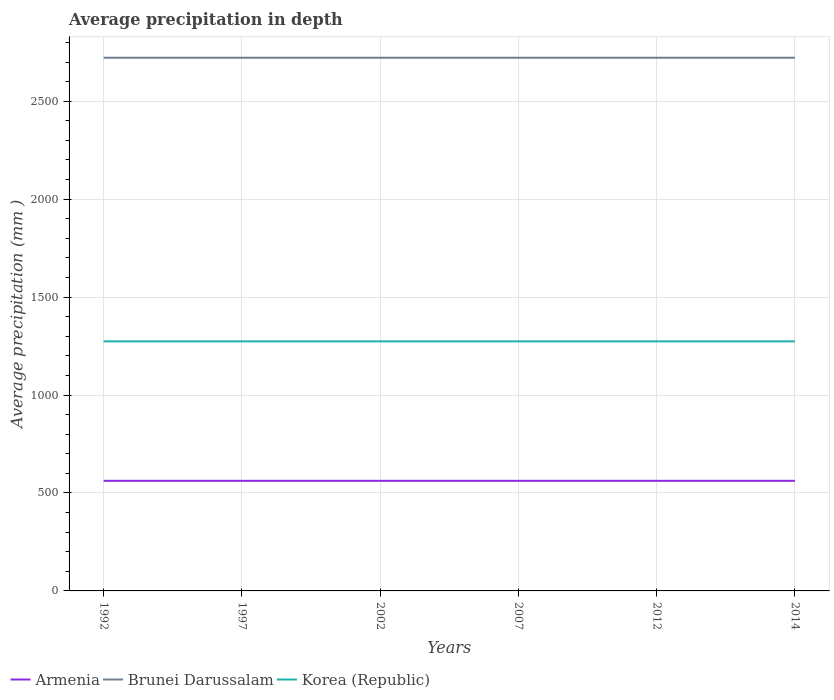How many different coloured lines are there?
Provide a succinct answer. 3. Does the line corresponding to Armenia intersect with the line corresponding to Korea (Republic)?
Provide a succinct answer. No. Is the number of lines equal to the number of legend labels?
Your answer should be very brief. Yes. Across all years, what is the maximum average precipitation in Korea (Republic)?
Ensure brevity in your answer.  1274. What is the total average precipitation in Korea (Republic) in the graph?
Your answer should be very brief. 0. Is the average precipitation in Brunei Darussalam strictly greater than the average precipitation in Korea (Republic) over the years?
Your answer should be very brief. No. Are the values on the major ticks of Y-axis written in scientific E-notation?
Your answer should be very brief. No. How many legend labels are there?
Your response must be concise. 3. What is the title of the graph?
Offer a very short reply. Average precipitation in depth. Does "Haiti" appear as one of the legend labels in the graph?
Keep it short and to the point. No. What is the label or title of the Y-axis?
Offer a terse response. Average precipitation (mm ). What is the Average precipitation (mm ) of Armenia in 1992?
Offer a very short reply. 562. What is the Average precipitation (mm ) of Brunei Darussalam in 1992?
Your answer should be compact. 2722. What is the Average precipitation (mm ) in Korea (Republic) in 1992?
Offer a terse response. 1274. What is the Average precipitation (mm ) of Armenia in 1997?
Give a very brief answer. 562. What is the Average precipitation (mm ) of Brunei Darussalam in 1997?
Your answer should be very brief. 2722. What is the Average precipitation (mm ) in Korea (Republic) in 1997?
Ensure brevity in your answer.  1274. What is the Average precipitation (mm ) of Armenia in 2002?
Provide a succinct answer. 562. What is the Average precipitation (mm ) in Brunei Darussalam in 2002?
Make the answer very short. 2722. What is the Average precipitation (mm ) in Korea (Republic) in 2002?
Your answer should be compact. 1274. What is the Average precipitation (mm ) of Armenia in 2007?
Provide a succinct answer. 562. What is the Average precipitation (mm ) in Brunei Darussalam in 2007?
Keep it short and to the point. 2722. What is the Average precipitation (mm ) of Korea (Republic) in 2007?
Your answer should be very brief. 1274. What is the Average precipitation (mm ) in Armenia in 2012?
Give a very brief answer. 562. What is the Average precipitation (mm ) in Brunei Darussalam in 2012?
Ensure brevity in your answer.  2722. What is the Average precipitation (mm ) in Korea (Republic) in 2012?
Provide a short and direct response. 1274. What is the Average precipitation (mm ) of Armenia in 2014?
Your response must be concise. 562. What is the Average precipitation (mm ) of Brunei Darussalam in 2014?
Offer a very short reply. 2722. What is the Average precipitation (mm ) of Korea (Republic) in 2014?
Provide a succinct answer. 1274. Across all years, what is the maximum Average precipitation (mm ) in Armenia?
Your response must be concise. 562. Across all years, what is the maximum Average precipitation (mm ) in Brunei Darussalam?
Offer a very short reply. 2722. Across all years, what is the maximum Average precipitation (mm ) in Korea (Republic)?
Offer a very short reply. 1274. Across all years, what is the minimum Average precipitation (mm ) in Armenia?
Provide a short and direct response. 562. Across all years, what is the minimum Average precipitation (mm ) of Brunei Darussalam?
Offer a very short reply. 2722. Across all years, what is the minimum Average precipitation (mm ) of Korea (Republic)?
Keep it short and to the point. 1274. What is the total Average precipitation (mm ) of Armenia in the graph?
Provide a succinct answer. 3372. What is the total Average precipitation (mm ) of Brunei Darussalam in the graph?
Offer a terse response. 1.63e+04. What is the total Average precipitation (mm ) in Korea (Republic) in the graph?
Give a very brief answer. 7644. What is the difference between the Average precipitation (mm ) of Armenia in 1992 and that in 1997?
Ensure brevity in your answer.  0. What is the difference between the Average precipitation (mm ) in Brunei Darussalam in 1992 and that in 1997?
Your answer should be compact. 0. What is the difference between the Average precipitation (mm ) of Korea (Republic) in 1992 and that in 1997?
Provide a succinct answer. 0. What is the difference between the Average precipitation (mm ) in Korea (Republic) in 1992 and that in 2002?
Give a very brief answer. 0. What is the difference between the Average precipitation (mm ) in Armenia in 1992 and that in 2007?
Give a very brief answer. 0. What is the difference between the Average precipitation (mm ) in Brunei Darussalam in 1992 and that in 2012?
Provide a short and direct response. 0. What is the difference between the Average precipitation (mm ) in Korea (Republic) in 1992 and that in 2012?
Your answer should be compact. 0. What is the difference between the Average precipitation (mm ) in Korea (Republic) in 1997 and that in 2002?
Give a very brief answer. 0. What is the difference between the Average precipitation (mm ) of Brunei Darussalam in 1997 and that in 2012?
Provide a short and direct response. 0. What is the difference between the Average precipitation (mm ) of Korea (Republic) in 1997 and that in 2014?
Your answer should be compact. 0. What is the difference between the Average precipitation (mm ) of Korea (Republic) in 2002 and that in 2012?
Offer a very short reply. 0. What is the difference between the Average precipitation (mm ) of Armenia in 2002 and that in 2014?
Offer a terse response. 0. What is the difference between the Average precipitation (mm ) in Korea (Republic) in 2007 and that in 2012?
Provide a short and direct response. 0. What is the difference between the Average precipitation (mm ) in Armenia in 2007 and that in 2014?
Your answer should be very brief. 0. What is the difference between the Average precipitation (mm ) of Brunei Darussalam in 2007 and that in 2014?
Offer a terse response. 0. What is the difference between the Average precipitation (mm ) of Armenia in 2012 and that in 2014?
Keep it short and to the point. 0. What is the difference between the Average precipitation (mm ) of Armenia in 1992 and the Average precipitation (mm ) of Brunei Darussalam in 1997?
Your answer should be very brief. -2160. What is the difference between the Average precipitation (mm ) of Armenia in 1992 and the Average precipitation (mm ) of Korea (Republic) in 1997?
Ensure brevity in your answer.  -712. What is the difference between the Average precipitation (mm ) of Brunei Darussalam in 1992 and the Average precipitation (mm ) of Korea (Republic) in 1997?
Offer a terse response. 1448. What is the difference between the Average precipitation (mm ) in Armenia in 1992 and the Average precipitation (mm ) in Brunei Darussalam in 2002?
Your response must be concise. -2160. What is the difference between the Average precipitation (mm ) of Armenia in 1992 and the Average precipitation (mm ) of Korea (Republic) in 2002?
Provide a short and direct response. -712. What is the difference between the Average precipitation (mm ) of Brunei Darussalam in 1992 and the Average precipitation (mm ) of Korea (Republic) in 2002?
Ensure brevity in your answer.  1448. What is the difference between the Average precipitation (mm ) of Armenia in 1992 and the Average precipitation (mm ) of Brunei Darussalam in 2007?
Ensure brevity in your answer.  -2160. What is the difference between the Average precipitation (mm ) of Armenia in 1992 and the Average precipitation (mm ) of Korea (Republic) in 2007?
Provide a short and direct response. -712. What is the difference between the Average precipitation (mm ) of Brunei Darussalam in 1992 and the Average precipitation (mm ) of Korea (Republic) in 2007?
Offer a very short reply. 1448. What is the difference between the Average precipitation (mm ) in Armenia in 1992 and the Average precipitation (mm ) in Brunei Darussalam in 2012?
Offer a very short reply. -2160. What is the difference between the Average precipitation (mm ) in Armenia in 1992 and the Average precipitation (mm ) in Korea (Republic) in 2012?
Provide a succinct answer. -712. What is the difference between the Average precipitation (mm ) of Brunei Darussalam in 1992 and the Average precipitation (mm ) of Korea (Republic) in 2012?
Your response must be concise. 1448. What is the difference between the Average precipitation (mm ) in Armenia in 1992 and the Average precipitation (mm ) in Brunei Darussalam in 2014?
Keep it short and to the point. -2160. What is the difference between the Average precipitation (mm ) in Armenia in 1992 and the Average precipitation (mm ) in Korea (Republic) in 2014?
Provide a succinct answer. -712. What is the difference between the Average precipitation (mm ) in Brunei Darussalam in 1992 and the Average precipitation (mm ) in Korea (Republic) in 2014?
Make the answer very short. 1448. What is the difference between the Average precipitation (mm ) in Armenia in 1997 and the Average precipitation (mm ) in Brunei Darussalam in 2002?
Keep it short and to the point. -2160. What is the difference between the Average precipitation (mm ) in Armenia in 1997 and the Average precipitation (mm ) in Korea (Republic) in 2002?
Your answer should be very brief. -712. What is the difference between the Average precipitation (mm ) in Brunei Darussalam in 1997 and the Average precipitation (mm ) in Korea (Republic) in 2002?
Keep it short and to the point. 1448. What is the difference between the Average precipitation (mm ) in Armenia in 1997 and the Average precipitation (mm ) in Brunei Darussalam in 2007?
Offer a very short reply. -2160. What is the difference between the Average precipitation (mm ) in Armenia in 1997 and the Average precipitation (mm ) in Korea (Republic) in 2007?
Give a very brief answer. -712. What is the difference between the Average precipitation (mm ) of Brunei Darussalam in 1997 and the Average precipitation (mm ) of Korea (Republic) in 2007?
Make the answer very short. 1448. What is the difference between the Average precipitation (mm ) in Armenia in 1997 and the Average precipitation (mm ) in Brunei Darussalam in 2012?
Make the answer very short. -2160. What is the difference between the Average precipitation (mm ) in Armenia in 1997 and the Average precipitation (mm ) in Korea (Republic) in 2012?
Provide a short and direct response. -712. What is the difference between the Average precipitation (mm ) in Brunei Darussalam in 1997 and the Average precipitation (mm ) in Korea (Republic) in 2012?
Offer a terse response. 1448. What is the difference between the Average precipitation (mm ) in Armenia in 1997 and the Average precipitation (mm ) in Brunei Darussalam in 2014?
Offer a terse response. -2160. What is the difference between the Average precipitation (mm ) in Armenia in 1997 and the Average precipitation (mm ) in Korea (Republic) in 2014?
Provide a short and direct response. -712. What is the difference between the Average precipitation (mm ) of Brunei Darussalam in 1997 and the Average precipitation (mm ) of Korea (Republic) in 2014?
Make the answer very short. 1448. What is the difference between the Average precipitation (mm ) of Armenia in 2002 and the Average precipitation (mm ) of Brunei Darussalam in 2007?
Keep it short and to the point. -2160. What is the difference between the Average precipitation (mm ) in Armenia in 2002 and the Average precipitation (mm ) in Korea (Republic) in 2007?
Your response must be concise. -712. What is the difference between the Average precipitation (mm ) in Brunei Darussalam in 2002 and the Average precipitation (mm ) in Korea (Republic) in 2007?
Offer a very short reply. 1448. What is the difference between the Average precipitation (mm ) in Armenia in 2002 and the Average precipitation (mm ) in Brunei Darussalam in 2012?
Offer a very short reply. -2160. What is the difference between the Average precipitation (mm ) in Armenia in 2002 and the Average precipitation (mm ) in Korea (Republic) in 2012?
Offer a very short reply. -712. What is the difference between the Average precipitation (mm ) in Brunei Darussalam in 2002 and the Average precipitation (mm ) in Korea (Republic) in 2012?
Provide a succinct answer. 1448. What is the difference between the Average precipitation (mm ) of Armenia in 2002 and the Average precipitation (mm ) of Brunei Darussalam in 2014?
Provide a short and direct response. -2160. What is the difference between the Average precipitation (mm ) in Armenia in 2002 and the Average precipitation (mm ) in Korea (Republic) in 2014?
Your response must be concise. -712. What is the difference between the Average precipitation (mm ) of Brunei Darussalam in 2002 and the Average precipitation (mm ) of Korea (Republic) in 2014?
Offer a terse response. 1448. What is the difference between the Average precipitation (mm ) in Armenia in 2007 and the Average precipitation (mm ) in Brunei Darussalam in 2012?
Your response must be concise. -2160. What is the difference between the Average precipitation (mm ) of Armenia in 2007 and the Average precipitation (mm ) of Korea (Republic) in 2012?
Offer a very short reply. -712. What is the difference between the Average precipitation (mm ) of Brunei Darussalam in 2007 and the Average precipitation (mm ) of Korea (Republic) in 2012?
Your answer should be compact. 1448. What is the difference between the Average precipitation (mm ) in Armenia in 2007 and the Average precipitation (mm ) in Brunei Darussalam in 2014?
Your answer should be compact. -2160. What is the difference between the Average precipitation (mm ) in Armenia in 2007 and the Average precipitation (mm ) in Korea (Republic) in 2014?
Offer a very short reply. -712. What is the difference between the Average precipitation (mm ) of Brunei Darussalam in 2007 and the Average precipitation (mm ) of Korea (Republic) in 2014?
Ensure brevity in your answer.  1448. What is the difference between the Average precipitation (mm ) in Armenia in 2012 and the Average precipitation (mm ) in Brunei Darussalam in 2014?
Give a very brief answer. -2160. What is the difference between the Average precipitation (mm ) in Armenia in 2012 and the Average precipitation (mm ) in Korea (Republic) in 2014?
Give a very brief answer. -712. What is the difference between the Average precipitation (mm ) in Brunei Darussalam in 2012 and the Average precipitation (mm ) in Korea (Republic) in 2014?
Your answer should be very brief. 1448. What is the average Average precipitation (mm ) in Armenia per year?
Your answer should be very brief. 562. What is the average Average precipitation (mm ) of Brunei Darussalam per year?
Keep it short and to the point. 2722. What is the average Average precipitation (mm ) of Korea (Republic) per year?
Give a very brief answer. 1274. In the year 1992, what is the difference between the Average precipitation (mm ) in Armenia and Average precipitation (mm ) in Brunei Darussalam?
Make the answer very short. -2160. In the year 1992, what is the difference between the Average precipitation (mm ) of Armenia and Average precipitation (mm ) of Korea (Republic)?
Your answer should be compact. -712. In the year 1992, what is the difference between the Average precipitation (mm ) of Brunei Darussalam and Average precipitation (mm ) of Korea (Republic)?
Ensure brevity in your answer.  1448. In the year 1997, what is the difference between the Average precipitation (mm ) of Armenia and Average precipitation (mm ) of Brunei Darussalam?
Keep it short and to the point. -2160. In the year 1997, what is the difference between the Average precipitation (mm ) of Armenia and Average precipitation (mm ) of Korea (Republic)?
Offer a very short reply. -712. In the year 1997, what is the difference between the Average precipitation (mm ) of Brunei Darussalam and Average precipitation (mm ) of Korea (Republic)?
Your response must be concise. 1448. In the year 2002, what is the difference between the Average precipitation (mm ) of Armenia and Average precipitation (mm ) of Brunei Darussalam?
Offer a terse response. -2160. In the year 2002, what is the difference between the Average precipitation (mm ) of Armenia and Average precipitation (mm ) of Korea (Republic)?
Provide a short and direct response. -712. In the year 2002, what is the difference between the Average precipitation (mm ) in Brunei Darussalam and Average precipitation (mm ) in Korea (Republic)?
Offer a very short reply. 1448. In the year 2007, what is the difference between the Average precipitation (mm ) of Armenia and Average precipitation (mm ) of Brunei Darussalam?
Your answer should be compact. -2160. In the year 2007, what is the difference between the Average precipitation (mm ) of Armenia and Average precipitation (mm ) of Korea (Republic)?
Provide a short and direct response. -712. In the year 2007, what is the difference between the Average precipitation (mm ) in Brunei Darussalam and Average precipitation (mm ) in Korea (Republic)?
Offer a very short reply. 1448. In the year 2012, what is the difference between the Average precipitation (mm ) in Armenia and Average precipitation (mm ) in Brunei Darussalam?
Provide a short and direct response. -2160. In the year 2012, what is the difference between the Average precipitation (mm ) of Armenia and Average precipitation (mm ) of Korea (Republic)?
Keep it short and to the point. -712. In the year 2012, what is the difference between the Average precipitation (mm ) of Brunei Darussalam and Average precipitation (mm ) of Korea (Republic)?
Give a very brief answer. 1448. In the year 2014, what is the difference between the Average precipitation (mm ) of Armenia and Average precipitation (mm ) of Brunei Darussalam?
Provide a short and direct response. -2160. In the year 2014, what is the difference between the Average precipitation (mm ) of Armenia and Average precipitation (mm ) of Korea (Republic)?
Give a very brief answer. -712. In the year 2014, what is the difference between the Average precipitation (mm ) of Brunei Darussalam and Average precipitation (mm ) of Korea (Republic)?
Your answer should be very brief. 1448. What is the ratio of the Average precipitation (mm ) of Armenia in 1992 to that in 1997?
Make the answer very short. 1. What is the ratio of the Average precipitation (mm ) in Korea (Republic) in 1992 to that in 1997?
Provide a succinct answer. 1. What is the ratio of the Average precipitation (mm ) of Armenia in 1992 to that in 2002?
Offer a terse response. 1. What is the ratio of the Average precipitation (mm ) of Korea (Republic) in 1992 to that in 2002?
Give a very brief answer. 1. What is the ratio of the Average precipitation (mm ) of Armenia in 1992 to that in 2007?
Provide a succinct answer. 1. What is the ratio of the Average precipitation (mm ) of Brunei Darussalam in 1992 to that in 2007?
Provide a succinct answer. 1. What is the ratio of the Average precipitation (mm ) in Korea (Republic) in 1992 to that in 2007?
Offer a terse response. 1. What is the ratio of the Average precipitation (mm ) of Armenia in 1992 to that in 2014?
Make the answer very short. 1. What is the ratio of the Average precipitation (mm ) in Brunei Darussalam in 1992 to that in 2014?
Provide a short and direct response. 1. What is the ratio of the Average precipitation (mm ) in Armenia in 1997 to that in 2002?
Keep it short and to the point. 1. What is the ratio of the Average precipitation (mm ) of Brunei Darussalam in 1997 to that in 2002?
Give a very brief answer. 1. What is the ratio of the Average precipitation (mm ) of Korea (Republic) in 1997 to that in 2002?
Offer a very short reply. 1. What is the ratio of the Average precipitation (mm ) in Armenia in 1997 to that in 2007?
Your answer should be compact. 1. What is the ratio of the Average precipitation (mm ) in Korea (Republic) in 1997 to that in 2007?
Keep it short and to the point. 1. What is the ratio of the Average precipitation (mm ) of Brunei Darussalam in 1997 to that in 2012?
Give a very brief answer. 1. What is the ratio of the Average precipitation (mm ) of Armenia in 1997 to that in 2014?
Give a very brief answer. 1. What is the ratio of the Average precipitation (mm ) in Brunei Darussalam in 1997 to that in 2014?
Your answer should be compact. 1. What is the ratio of the Average precipitation (mm ) in Armenia in 2002 to that in 2007?
Keep it short and to the point. 1. What is the ratio of the Average precipitation (mm ) in Armenia in 2002 to that in 2012?
Provide a short and direct response. 1. What is the ratio of the Average precipitation (mm ) of Korea (Republic) in 2002 to that in 2012?
Provide a short and direct response. 1. What is the ratio of the Average precipitation (mm ) in Brunei Darussalam in 2002 to that in 2014?
Give a very brief answer. 1. What is the ratio of the Average precipitation (mm ) in Korea (Republic) in 2002 to that in 2014?
Provide a short and direct response. 1. What is the ratio of the Average precipitation (mm ) in Armenia in 2007 to that in 2012?
Your answer should be compact. 1. What is the ratio of the Average precipitation (mm ) in Armenia in 2007 to that in 2014?
Ensure brevity in your answer.  1. What is the ratio of the Average precipitation (mm ) of Korea (Republic) in 2007 to that in 2014?
Your response must be concise. 1. What is the ratio of the Average precipitation (mm ) of Armenia in 2012 to that in 2014?
Give a very brief answer. 1. What is the ratio of the Average precipitation (mm ) of Korea (Republic) in 2012 to that in 2014?
Your answer should be very brief. 1. What is the difference between the highest and the second highest Average precipitation (mm ) in Armenia?
Offer a very short reply. 0. What is the difference between the highest and the second highest Average precipitation (mm ) of Korea (Republic)?
Offer a very short reply. 0. What is the difference between the highest and the lowest Average precipitation (mm ) of Brunei Darussalam?
Provide a short and direct response. 0. 